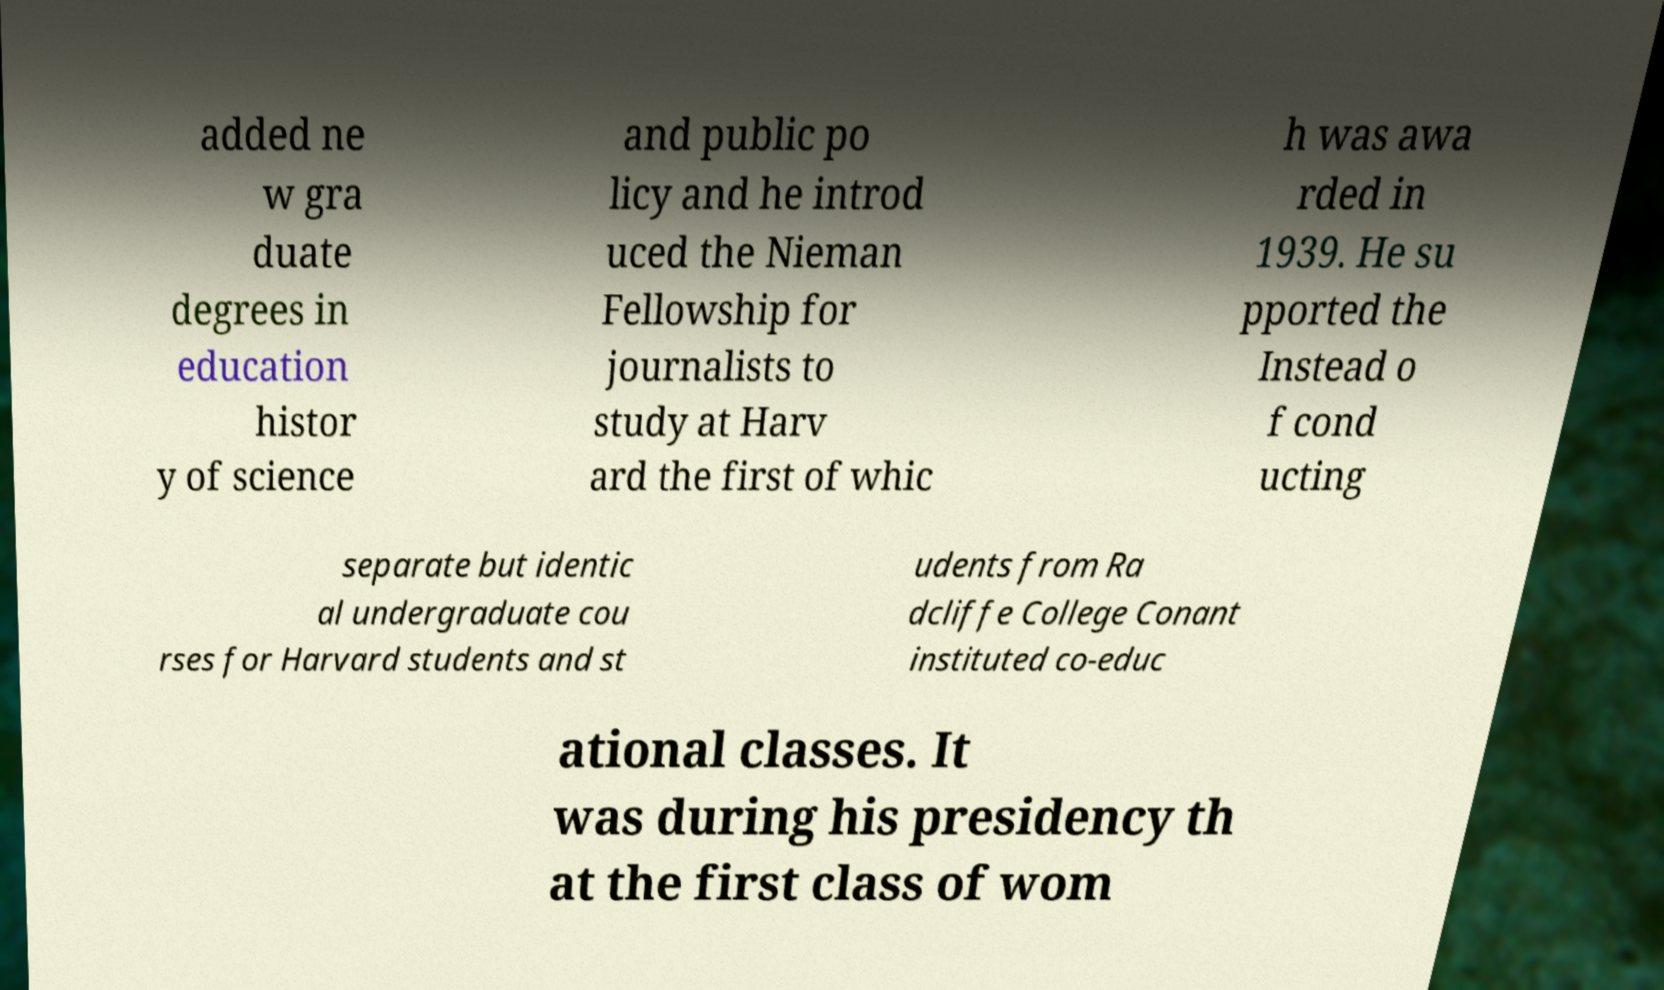Can you accurately transcribe the text from the provided image for me? added ne w gra duate degrees in education histor y of science and public po licy and he introd uced the Nieman Fellowship for journalists to study at Harv ard the first of whic h was awa rded in 1939. He su pported the Instead o f cond ucting separate but identic al undergraduate cou rses for Harvard students and st udents from Ra dcliffe College Conant instituted co-educ ational classes. It was during his presidency th at the first class of wom 